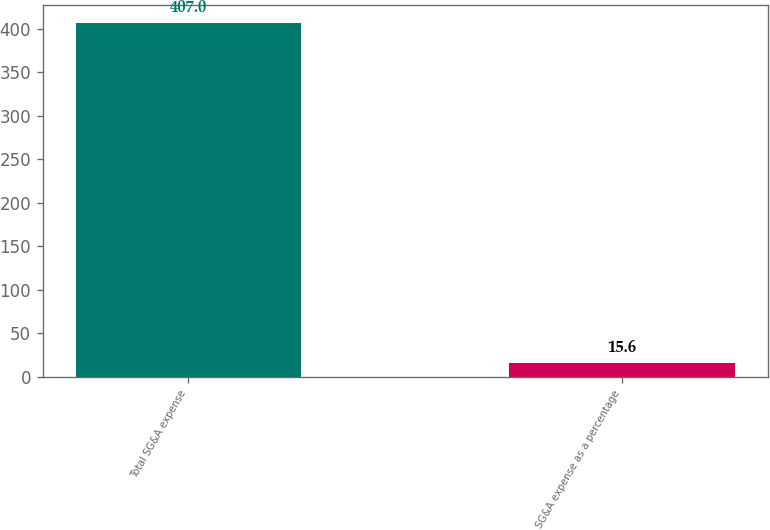<chart> <loc_0><loc_0><loc_500><loc_500><bar_chart><fcel>Total SG&A expense<fcel>SG&A expense as a percentage<nl><fcel>407<fcel>15.6<nl></chart> 